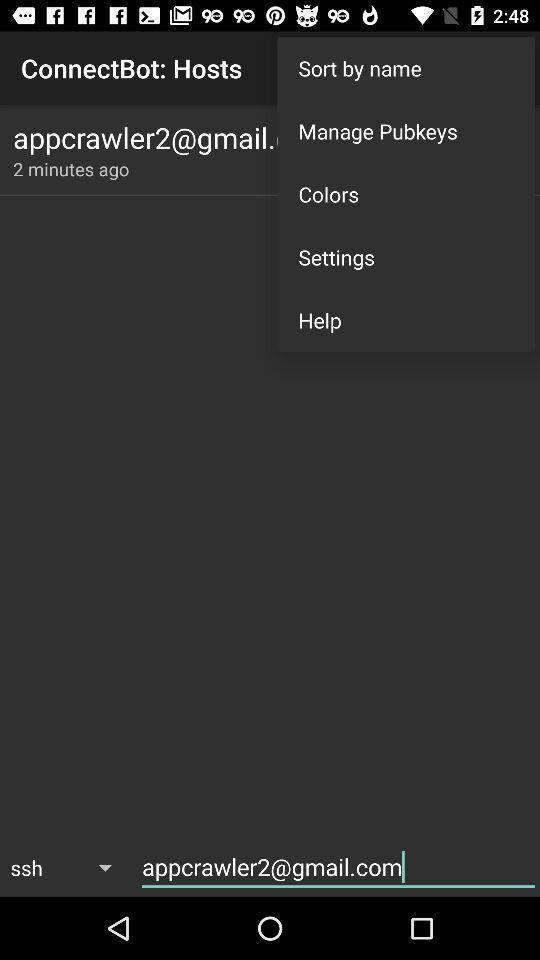How do I connect to a Bot host?
When the provided information is insufficient, respond with <no answer>. <no answer> 